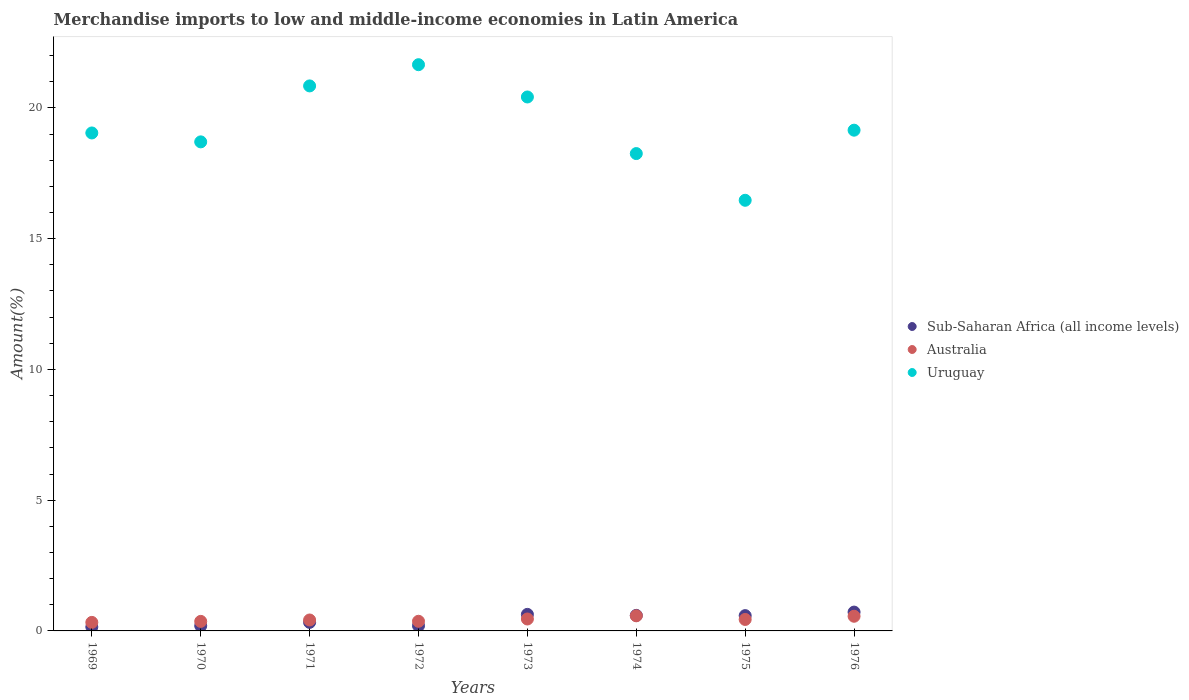How many different coloured dotlines are there?
Ensure brevity in your answer.  3. Is the number of dotlines equal to the number of legend labels?
Give a very brief answer. Yes. What is the percentage of amount earned from merchandise imports in Australia in 1975?
Offer a very short reply. 0.44. Across all years, what is the maximum percentage of amount earned from merchandise imports in Sub-Saharan Africa (all income levels)?
Provide a short and direct response. 0.72. Across all years, what is the minimum percentage of amount earned from merchandise imports in Australia?
Keep it short and to the point. 0.33. In which year was the percentage of amount earned from merchandise imports in Sub-Saharan Africa (all income levels) minimum?
Offer a very short reply. 1969. What is the total percentage of amount earned from merchandise imports in Uruguay in the graph?
Your answer should be compact. 154.52. What is the difference between the percentage of amount earned from merchandise imports in Sub-Saharan Africa (all income levels) in 1972 and that in 1974?
Ensure brevity in your answer.  -0.4. What is the difference between the percentage of amount earned from merchandise imports in Uruguay in 1969 and the percentage of amount earned from merchandise imports in Sub-Saharan Africa (all income levels) in 1976?
Ensure brevity in your answer.  18.32. What is the average percentage of amount earned from merchandise imports in Australia per year?
Make the answer very short. 0.44. In the year 1976, what is the difference between the percentage of amount earned from merchandise imports in Sub-Saharan Africa (all income levels) and percentage of amount earned from merchandise imports in Uruguay?
Your response must be concise. -18.43. What is the ratio of the percentage of amount earned from merchandise imports in Australia in 1969 to that in 1975?
Your answer should be compact. 0.74. Is the difference between the percentage of amount earned from merchandise imports in Sub-Saharan Africa (all income levels) in 1970 and 1973 greater than the difference between the percentage of amount earned from merchandise imports in Uruguay in 1970 and 1973?
Your answer should be very brief. Yes. What is the difference between the highest and the second highest percentage of amount earned from merchandise imports in Sub-Saharan Africa (all income levels)?
Provide a succinct answer. 0.09. What is the difference between the highest and the lowest percentage of amount earned from merchandise imports in Uruguay?
Give a very brief answer. 5.19. In how many years, is the percentage of amount earned from merchandise imports in Sub-Saharan Africa (all income levels) greater than the average percentage of amount earned from merchandise imports in Sub-Saharan Africa (all income levels) taken over all years?
Keep it short and to the point. 4. How many dotlines are there?
Keep it short and to the point. 3. How many years are there in the graph?
Offer a very short reply. 8. Are the values on the major ticks of Y-axis written in scientific E-notation?
Ensure brevity in your answer.  No. How are the legend labels stacked?
Your response must be concise. Vertical. What is the title of the graph?
Offer a terse response. Merchandise imports to low and middle-income economies in Latin America. Does "Equatorial Guinea" appear as one of the legend labels in the graph?
Your answer should be compact. No. What is the label or title of the X-axis?
Offer a very short reply. Years. What is the label or title of the Y-axis?
Offer a terse response. Amount(%). What is the Amount(%) in Sub-Saharan Africa (all income levels) in 1969?
Your answer should be very brief. 0.15. What is the Amount(%) in Australia in 1969?
Your response must be concise. 0.33. What is the Amount(%) of Uruguay in 1969?
Provide a succinct answer. 19.04. What is the Amount(%) of Sub-Saharan Africa (all income levels) in 1970?
Provide a succinct answer. 0.2. What is the Amount(%) in Australia in 1970?
Offer a terse response. 0.36. What is the Amount(%) of Uruguay in 1970?
Provide a short and direct response. 18.7. What is the Amount(%) in Sub-Saharan Africa (all income levels) in 1971?
Give a very brief answer. 0.33. What is the Amount(%) of Australia in 1971?
Give a very brief answer. 0.42. What is the Amount(%) in Uruguay in 1971?
Your response must be concise. 20.84. What is the Amount(%) of Sub-Saharan Africa (all income levels) in 1972?
Your response must be concise. 0.2. What is the Amount(%) of Australia in 1972?
Your response must be concise. 0.37. What is the Amount(%) in Uruguay in 1972?
Give a very brief answer. 21.65. What is the Amount(%) of Sub-Saharan Africa (all income levels) in 1973?
Give a very brief answer. 0.63. What is the Amount(%) of Australia in 1973?
Provide a short and direct response. 0.46. What is the Amount(%) of Uruguay in 1973?
Give a very brief answer. 20.42. What is the Amount(%) of Sub-Saharan Africa (all income levels) in 1974?
Your answer should be very brief. 0.59. What is the Amount(%) in Australia in 1974?
Your answer should be very brief. 0.58. What is the Amount(%) of Uruguay in 1974?
Your answer should be very brief. 18.25. What is the Amount(%) of Sub-Saharan Africa (all income levels) in 1975?
Offer a very short reply. 0.58. What is the Amount(%) in Australia in 1975?
Make the answer very short. 0.44. What is the Amount(%) of Uruguay in 1975?
Offer a very short reply. 16.47. What is the Amount(%) in Sub-Saharan Africa (all income levels) in 1976?
Make the answer very short. 0.72. What is the Amount(%) in Australia in 1976?
Provide a short and direct response. 0.56. What is the Amount(%) in Uruguay in 1976?
Give a very brief answer. 19.15. Across all years, what is the maximum Amount(%) in Sub-Saharan Africa (all income levels)?
Provide a short and direct response. 0.72. Across all years, what is the maximum Amount(%) of Australia?
Provide a short and direct response. 0.58. Across all years, what is the maximum Amount(%) in Uruguay?
Make the answer very short. 21.65. Across all years, what is the minimum Amount(%) of Sub-Saharan Africa (all income levels)?
Your answer should be compact. 0.15. Across all years, what is the minimum Amount(%) in Australia?
Your answer should be very brief. 0.33. Across all years, what is the minimum Amount(%) in Uruguay?
Ensure brevity in your answer.  16.47. What is the total Amount(%) in Sub-Saharan Africa (all income levels) in the graph?
Give a very brief answer. 3.4. What is the total Amount(%) of Australia in the graph?
Give a very brief answer. 3.51. What is the total Amount(%) in Uruguay in the graph?
Offer a very short reply. 154.52. What is the difference between the Amount(%) in Sub-Saharan Africa (all income levels) in 1969 and that in 1970?
Make the answer very short. -0.04. What is the difference between the Amount(%) in Australia in 1969 and that in 1970?
Your answer should be very brief. -0.04. What is the difference between the Amount(%) in Uruguay in 1969 and that in 1970?
Provide a succinct answer. 0.34. What is the difference between the Amount(%) in Sub-Saharan Africa (all income levels) in 1969 and that in 1971?
Your response must be concise. -0.18. What is the difference between the Amount(%) in Australia in 1969 and that in 1971?
Offer a very short reply. -0.09. What is the difference between the Amount(%) of Uruguay in 1969 and that in 1971?
Your response must be concise. -1.8. What is the difference between the Amount(%) in Sub-Saharan Africa (all income levels) in 1969 and that in 1972?
Offer a very short reply. -0.05. What is the difference between the Amount(%) in Australia in 1969 and that in 1972?
Your answer should be very brief. -0.04. What is the difference between the Amount(%) of Uruguay in 1969 and that in 1972?
Ensure brevity in your answer.  -2.61. What is the difference between the Amount(%) in Sub-Saharan Africa (all income levels) in 1969 and that in 1973?
Ensure brevity in your answer.  -0.48. What is the difference between the Amount(%) in Australia in 1969 and that in 1973?
Give a very brief answer. -0.13. What is the difference between the Amount(%) of Uruguay in 1969 and that in 1973?
Keep it short and to the point. -1.38. What is the difference between the Amount(%) in Sub-Saharan Africa (all income levels) in 1969 and that in 1974?
Your answer should be compact. -0.44. What is the difference between the Amount(%) of Australia in 1969 and that in 1974?
Keep it short and to the point. -0.25. What is the difference between the Amount(%) in Uruguay in 1969 and that in 1974?
Your response must be concise. 0.79. What is the difference between the Amount(%) in Sub-Saharan Africa (all income levels) in 1969 and that in 1975?
Give a very brief answer. -0.43. What is the difference between the Amount(%) in Australia in 1969 and that in 1975?
Your response must be concise. -0.11. What is the difference between the Amount(%) of Uruguay in 1969 and that in 1975?
Your response must be concise. 2.57. What is the difference between the Amount(%) of Sub-Saharan Africa (all income levels) in 1969 and that in 1976?
Provide a short and direct response. -0.57. What is the difference between the Amount(%) of Australia in 1969 and that in 1976?
Provide a short and direct response. -0.24. What is the difference between the Amount(%) in Uruguay in 1969 and that in 1976?
Offer a very short reply. -0.11. What is the difference between the Amount(%) of Sub-Saharan Africa (all income levels) in 1970 and that in 1971?
Offer a terse response. -0.13. What is the difference between the Amount(%) of Australia in 1970 and that in 1971?
Ensure brevity in your answer.  -0.05. What is the difference between the Amount(%) in Uruguay in 1970 and that in 1971?
Your response must be concise. -2.14. What is the difference between the Amount(%) in Sub-Saharan Africa (all income levels) in 1970 and that in 1972?
Give a very brief answer. -0. What is the difference between the Amount(%) in Australia in 1970 and that in 1972?
Make the answer very short. -0. What is the difference between the Amount(%) of Uruguay in 1970 and that in 1972?
Provide a short and direct response. -2.95. What is the difference between the Amount(%) of Sub-Saharan Africa (all income levels) in 1970 and that in 1973?
Provide a succinct answer. -0.44. What is the difference between the Amount(%) of Australia in 1970 and that in 1973?
Give a very brief answer. -0.09. What is the difference between the Amount(%) in Uruguay in 1970 and that in 1973?
Give a very brief answer. -1.72. What is the difference between the Amount(%) in Sub-Saharan Africa (all income levels) in 1970 and that in 1974?
Provide a short and direct response. -0.4. What is the difference between the Amount(%) of Australia in 1970 and that in 1974?
Your answer should be very brief. -0.21. What is the difference between the Amount(%) in Uruguay in 1970 and that in 1974?
Make the answer very short. 0.45. What is the difference between the Amount(%) in Sub-Saharan Africa (all income levels) in 1970 and that in 1975?
Provide a short and direct response. -0.39. What is the difference between the Amount(%) of Australia in 1970 and that in 1975?
Your answer should be compact. -0.07. What is the difference between the Amount(%) in Uruguay in 1970 and that in 1975?
Your answer should be compact. 2.23. What is the difference between the Amount(%) of Sub-Saharan Africa (all income levels) in 1970 and that in 1976?
Offer a terse response. -0.52. What is the difference between the Amount(%) in Australia in 1970 and that in 1976?
Your response must be concise. -0.2. What is the difference between the Amount(%) of Uruguay in 1970 and that in 1976?
Provide a short and direct response. -0.45. What is the difference between the Amount(%) of Sub-Saharan Africa (all income levels) in 1971 and that in 1972?
Provide a short and direct response. 0.13. What is the difference between the Amount(%) in Australia in 1971 and that in 1972?
Ensure brevity in your answer.  0.05. What is the difference between the Amount(%) in Uruguay in 1971 and that in 1972?
Your answer should be compact. -0.81. What is the difference between the Amount(%) in Sub-Saharan Africa (all income levels) in 1971 and that in 1973?
Ensure brevity in your answer.  -0.31. What is the difference between the Amount(%) in Australia in 1971 and that in 1973?
Ensure brevity in your answer.  -0.04. What is the difference between the Amount(%) of Uruguay in 1971 and that in 1973?
Offer a terse response. 0.42. What is the difference between the Amount(%) in Sub-Saharan Africa (all income levels) in 1971 and that in 1974?
Your response must be concise. -0.27. What is the difference between the Amount(%) in Australia in 1971 and that in 1974?
Provide a short and direct response. -0.16. What is the difference between the Amount(%) of Uruguay in 1971 and that in 1974?
Provide a succinct answer. 2.59. What is the difference between the Amount(%) in Sub-Saharan Africa (all income levels) in 1971 and that in 1975?
Offer a very short reply. -0.26. What is the difference between the Amount(%) of Australia in 1971 and that in 1975?
Your answer should be very brief. -0.02. What is the difference between the Amount(%) in Uruguay in 1971 and that in 1975?
Give a very brief answer. 4.37. What is the difference between the Amount(%) of Sub-Saharan Africa (all income levels) in 1971 and that in 1976?
Your response must be concise. -0.39. What is the difference between the Amount(%) in Australia in 1971 and that in 1976?
Provide a short and direct response. -0.14. What is the difference between the Amount(%) in Uruguay in 1971 and that in 1976?
Ensure brevity in your answer.  1.69. What is the difference between the Amount(%) of Sub-Saharan Africa (all income levels) in 1972 and that in 1973?
Your answer should be very brief. -0.43. What is the difference between the Amount(%) in Australia in 1972 and that in 1973?
Provide a succinct answer. -0.09. What is the difference between the Amount(%) of Uruguay in 1972 and that in 1973?
Your answer should be compact. 1.23. What is the difference between the Amount(%) in Sub-Saharan Africa (all income levels) in 1972 and that in 1974?
Your answer should be compact. -0.4. What is the difference between the Amount(%) in Australia in 1972 and that in 1974?
Make the answer very short. -0.21. What is the difference between the Amount(%) in Uruguay in 1972 and that in 1974?
Keep it short and to the point. 3.4. What is the difference between the Amount(%) in Sub-Saharan Africa (all income levels) in 1972 and that in 1975?
Keep it short and to the point. -0.39. What is the difference between the Amount(%) in Australia in 1972 and that in 1975?
Ensure brevity in your answer.  -0.07. What is the difference between the Amount(%) of Uruguay in 1972 and that in 1975?
Your answer should be very brief. 5.19. What is the difference between the Amount(%) of Sub-Saharan Africa (all income levels) in 1972 and that in 1976?
Your answer should be very brief. -0.52. What is the difference between the Amount(%) in Australia in 1972 and that in 1976?
Make the answer very short. -0.19. What is the difference between the Amount(%) in Uruguay in 1972 and that in 1976?
Offer a very short reply. 2.5. What is the difference between the Amount(%) of Sub-Saharan Africa (all income levels) in 1973 and that in 1974?
Offer a very short reply. 0.04. What is the difference between the Amount(%) in Australia in 1973 and that in 1974?
Offer a terse response. -0.12. What is the difference between the Amount(%) of Uruguay in 1973 and that in 1974?
Keep it short and to the point. 2.16. What is the difference between the Amount(%) in Sub-Saharan Africa (all income levels) in 1973 and that in 1975?
Ensure brevity in your answer.  0.05. What is the difference between the Amount(%) of Australia in 1973 and that in 1975?
Make the answer very short. 0.02. What is the difference between the Amount(%) in Uruguay in 1973 and that in 1975?
Your answer should be very brief. 3.95. What is the difference between the Amount(%) of Sub-Saharan Africa (all income levels) in 1973 and that in 1976?
Offer a very short reply. -0.09. What is the difference between the Amount(%) in Australia in 1973 and that in 1976?
Provide a succinct answer. -0.1. What is the difference between the Amount(%) of Uruguay in 1973 and that in 1976?
Provide a short and direct response. 1.27. What is the difference between the Amount(%) in Sub-Saharan Africa (all income levels) in 1974 and that in 1975?
Make the answer very short. 0.01. What is the difference between the Amount(%) in Australia in 1974 and that in 1975?
Offer a very short reply. 0.14. What is the difference between the Amount(%) in Uruguay in 1974 and that in 1975?
Your response must be concise. 1.79. What is the difference between the Amount(%) in Sub-Saharan Africa (all income levels) in 1974 and that in 1976?
Give a very brief answer. -0.13. What is the difference between the Amount(%) of Australia in 1974 and that in 1976?
Give a very brief answer. 0.02. What is the difference between the Amount(%) of Uruguay in 1974 and that in 1976?
Offer a terse response. -0.89. What is the difference between the Amount(%) of Sub-Saharan Africa (all income levels) in 1975 and that in 1976?
Make the answer very short. -0.14. What is the difference between the Amount(%) of Australia in 1975 and that in 1976?
Provide a succinct answer. -0.12. What is the difference between the Amount(%) of Uruguay in 1975 and that in 1976?
Make the answer very short. -2.68. What is the difference between the Amount(%) in Sub-Saharan Africa (all income levels) in 1969 and the Amount(%) in Australia in 1970?
Your answer should be very brief. -0.21. What is the difference between the Amount(%) in Sub-Saharan Africa (all income levels) in 1969 and the Amount(%) in Uruguay in 1970?
Provide a succinct answer. -18.55. What is the difference between the Amount(%) in Australia in 1969 and the Amount(%) in Uruguay in 1970?
Provide a succinct answer. -18.38. What is the difference between the Amount(%) in Sub-Saharan Africa (all income levels) in 1969 and the Amount(%) in Australia in 1971?
Offer a terse response. -0.27. What is the difference between the Amount(%) of Sub-Saharan Africa (all income levels) in 1969 and the Amount(%) of Uruguay in 1971?
Provide a short and direct response. -20.69. What is the difference between the Amount(%) of Australia in 1969 and the Amount(%) of Uruguay in 1971?
Make the answer very short. -20.52. What is the difference between the Amount(%) of Sub-Saharan Africa (all income levels) in 1969 and the Amount(%) of Australia in 1972?
Your response must be concise. -0.22. What is the difference between the Amount(%) of Sub-Saharan Africa (all income levels) in 1969 and the Amount(%) of Uruguay in 1972?
Provide a succinct answer. -21.5. What is the difference between the Amount(%) of Australia in 1969 and the Amount(%) of Uruguay in 1972?
Keep it short and to the point. -21.33. What is the difference between the Amount(%) in Sub-Saharan Africa (all income levels) in 1969 and the Amount(%) in Australia in 1973?
Your answer should be compact. -0.31. What is the difference between the Amount(%) in Sub-Saharan Africa (all income levels) in 1969 and the Amount(%) in Uruguay in 1973?
Offer a very short reply. -20.27. What is the difference between the Amount(%) of Australia in 1969 and the Amount(%) of Uruguay in 1973?
Your response must be concise. -20.09. What is the difference between the Amount(%) of Sub-Saharan Africa (all income levels) in 1969 and the Amount(%) of Australia in 1974?
Your response must be concise. -0.43. What is the difference between the Amount(%) in Sub-Saharan Africa (all income levels) in 1969 and the Amount(%) in Uruguay in 1974?
Ensure brevity in your answer.  -18.1. What is the difference between the Amount(%) in Australia in 1969 and the Amount(%) in Uruguay in 1974?
Ensure brevity in your answer.  -17.93. What is the difference between the Amount(%) of Sub-Saharan Africa (all income levels) in 1969 and the Amount(%) of Australia in 1975?
Give a very brief answer. -0.29. What is the difference between the Amount(%) in Sub-Saharan Africa (all income levels) in 1969 and the Amount(%) in Uruguay in 1975?
Give a very brief answer. -16.32. What is the difference between the Amount(%) of Australia in 1969 and the Amount(%) of Uruguay in 1975?
Offer a terse response. -16.14. What is the difference between the Amount(%) of Sub-Saharan Africa (all income levels) in 1969 and the Amount(%) of Australia in 1976?
Ensure brevity in your answer.  -0.41. What is the difference between the Amount(%) of Sub-Saharan Africa (all income levels) in 1969 and the Amount(%) of Uruguay in 1976?
Make the answer very short. -19. What is the difference between the Amount(%) in Australia in 1969 and the Amount(%) in Uruguay in 1976?
Ensure brevity in your answer.  -18.82. What is the difference between the Amount(%) in Sub-Saharan Africa (all income levels) in 1970 and the Amount(%) in Australia in 1971?
Your answer should be very brief. -0.22. What is the difference between the Amount(%) of Sub-Saharan Africa (all income levels) in 1970 and the Amount(%) of Uruguay in 1971?
Provide a succinct answer. -20.65. What is the difference between the Amount(%) of Australia in 1970 and the Amount(%) of Uruguay in 1971?
Give a very brief answer. -20.48. What is the difference between the Amount(%) of Sub-Saharan Africa (all income levels) in 1970 and the Amount(%) of Australia in 1972?
Offer a terse response. -0.17. What is the difference between the Amount(%) of Sub-Saharan Africa (all income levels) in 1970 and the Amount(%) of Uruguay in 1972?
Offer a very short reply. -21.46. What is the difference between the Amount(%) in Australia in 1970 and the Amount(%) in Uruguay in 1972?
Provide a short and direct response. -21.29. What is the difference between the Amount(%) in Sub-Saharan Africa (all income levels) in 1970 and the Amount(%) in Australia in 1973?
Provide a short and direct response. -0.26. What is the difference between the Amount(%) in Sub-Saharan Africa (all income levels) in 1970 and the Amount(%) in Uruguay in 1973?
Make the answer very short. -20.22. What is the difference between the Amount(%) of Australia in 1970 and the Amount(%) of Uruguay in 1973?
Your response must be concise. -20.05. What is the difference between the Amount(%) in Sub-Saharan Africa (all income levels) in 1970 and the Amount(%) in Australia in 1974?
Make the answer very short. -0.38. What is the difference between the Amount(%) of Sub-Saharan Africa (all income levels) in 1970 and the Amount(%) of Uruguay in 1974?
Offer a very short reply. -18.06. What is the difference between the Amount(%) in Australia in 1970 and the Amount(%) in Uruguay in 1974?
Give a very brief answer. -17.89. What is the difference between the Amount(%) in Sub-Saharan Africa (all income levels) in 1970 and the Amount(%) in Australia in 1975?
Your answer should be compact. -0.24. What is the difference between the Amount(%) of Sub-Saharan Africa (all income levels) in 1970 and the Amount(%) of Uruguay in 1975?
Your response must be concise. -16.27. What is the difference between the Amount(%) of Australia in 1970 and the Amount(%) of Uruguay in 1975?
Your answer should be compact. -16.1. What is the difference between the Amount(%) in Sub-Saharan Africa (all income levels) in 1970 and the Amount(%) in Australia in 1976?
Offer a very short reply. -0.37. What is the difference between the Amount(%) in Sub-Saharan Africa (all income levels) in 1970 and the Amount(%) in Uruguay in 1976?
Your answer should be very brief. -18.95. What is the difference between the Amount(%) of Australia in 1970 and the Amount(%) of Uruguay in 1976?
Your answer should be compact. -18.78. What is the difference between the Amount(%) of Sub-Saharan Africa (all income levels) in 1971 and the Amount(%) of Australia in 1972?
Give a very brief answer. -0.04. What is the difference between the Amount(%) in Sub-Saharan Africa (all income levels) in 1971 and the Amount(%) in Uruguay in 1972?
Offer a terse response. -21.33. What is the difference between the Amount(%) in Australia in 1971 and the Amount(%) in Uruguay in 1972?
Give a very brief answer. -21.23. What is the difference between the Amount(%) of Sub-Saharan Africa (all income levels) in 1971 and the Amount(%) of Australia in 1973?
Your answer should be very brief. -0.13. What is the difference between the Amount(%) of Sub-Saharan Africa (all income levels) in 1971 and the Amount(%) of Uruguay in 1973?
Provide a short and direct response. -20.09. What is the difference between the Amount(%) in Australia in 1971 and the Amount(%) in Uruguay in 1973?
Give a very brief answer. -20. What is the difference between the Amount(%) of Sub-Saharan Africa (all income levels) in 1971 and the Amount(%) of Australia in 1974?
Offer a very short reply. -0.25. What is the difference between the Amount(%) in Sub-Saharan Africa (all income levels) in 1971 and the Amount(%) in Uruguay in 1974?
Give a very brief answer. -17.93. What is the difference between the Amount(%) in Australia in 1971 and the Amount(%) in Uruguay in 1974?
Offer a terse response. -17.84. What is the difference between the Amount(%) of Sub-Saharan Africa (all income levels) in 1971 and the Amount(%) of Australia in 1975?
Give a very brief answer. -0.11. What is the difference between the Amount(%) in Sub-Saharan Africa (all income levels) in 1971 and the Amount(%) in Uruguay in 1975?
Provide a succinct answer. -16.14. What is the difference between the Amount(%) of Australia in 1971 and the Amount(%) of Uruguay in 1975?
Provide a short and direct response. -16.05. What is the difference between the Amount(%) of Sub-Saharan Africa (all income levels) in 1971 and the Amount(%) of Australia in 1976?
Your answer should be compact. -0.23. What is the difference between the Amount(%) in Sub-Saharan Africa (all income levels) in 1971 and the Amount(%) in Uruguay in 1976?
Your response must be concise. -18.82. What is the difference between the Amount(%) of Australia in 1971 and the Amount(%) of Uruguay in 1976?
Offer a very short reply. -18.73. What is the difference between the Amount(%) in Sub-Saharan Africa (all income levels) in 1972 and the Amount(%) in Australia in 1973?
Make the answer very short. -0.26. What is the difference between the Amount(%) of Sub-Saharan Africa (all income levels) in 1972 and the Amount(%) of Uruguay in 1973?
Your response must be concise. -20.22. What is the difference between the Amount(%) of Australia in 1972 and the Amount(%) of Uruguay in 1973?
Make the answer very short. -20.05. What is the difference between the Amount(%) of Sub-Saharan Africa (all income levels) in 1972 and the Amount(%) of Australia in 1974?
Provide a short and direct response. -0.38. What is the difference between the Amount(%) of Sub-Saharan Africa (all income levels) in 1972 and the Amount(%) of Uruguay in 1974?
Your response must be concise. -18.06. What is the difference between the Amount(%) of Australia in 1972 and the Amount(%) of Uruguay in 1974?
Make the answer very short. -17.88. What is the difference between the Amount(%) of Sub-Saharan Africa (all income levels) in 1972 and the Amount(%) of Australia in 1975?
Your answer should be compact. -0.24. What is the difference between the Amount(%) in Sub-Saharan Africa (all income levels) in 1972 and the Amount(%) in Uruguay in 1975?
Provide a succinct answer. -16.27. What is the difference between the Amount(%) of Australia in 1972 and the Amount(%) of Uruguay in 1975?
Make the answer very short. -16.1. What is the difference between the Amount(%) of Sub-Saharan Africa (all income levels) in 1972 and the Amount(%) of Australia in 1976?
Keep it short and to the point. -0.36. What is the difference between the Amount(%) of Sub-Saharan Africa (all income levels) in 1972 and the Amount(%) of Uruguay in 1976?
Your answer should be very brief. -18.95. What is the difference between the Amount(%) in Australia in 1972 and the Amount(%) in Uruguay in 1976?
Give a very brief answer. -18.78. What is the difference between the Amount(%) in Sub-Saharan Africa (all income levels) in 1973 and the Amount(%) in Australia in 1974?
Keep it short and to the point. 0.05. What is the difference between the Amount(%) in Sub-Saharan Africa (all income levels) in 1973 and the Amount(%) in Uruguay in 1974?
Offer a terse response. -17.62. What is the difference between the Amount(%) in Australia in 1973 and the Amount(%) in Uruguay in 1974?
Your answer should be compact. -17.8. What is the difference between the Amount(%) in Sub-Saharan Africa (all income levels) in 1973 and the Amount(%) in Australia in 1975?
Offer a terse response. 0.19. What is the difference between the Amount(%) of Sub-Saharan Africa (all income levels) in 1973 and the Amount(%) of Uruguay in 1975?
Provide a short and direct response. -15.83. What is the difference between the Amount(%) in Australia in 1973 and the Amount(%) in Uruguay in 1975?
Offer a terse response. -16.01. What is the difference between the Amount(%) of Sub-Saharan Africa (all income levels) in 1973 and the Amount(%) of Australia in 1976?
Your response must be concise. 0.07. What is the difference between the Amount(%) of Sub-Saharan Africa (all income levels) in 1973 and the Amount(%) of Uruguay in 1976?
Ensure brevity in your answer.  -18.52. What is the difference between the Amount(%) in Australia in 1973 and the Amount(%) in Uruguay in 1976?
Your response must be concise. -18.69. What is the difference between the Amount(%) of Sub-Saharan Africa (all income levels) in 1974 and the Amount(%) of Australia in 1975?
Offer a very short reply. 0.16. What is the difference between the Amount(%) of Sub-Saharan Africa (all income levels) in 1974 and the Amount(%) of Uruguay in 1975?
Keep it short and to the point. -15.87. What is the difference between the Amount(%) in Australia in 1974 and the Amount(%) in Uruguay in 1975?
Give a very brief answer. -15.89. What is the difference between the Amount(%) in Sub-Saharan Africa (all income levels) in 1974 and the Amount(%) in Australia in 1976?
Offer a very short reply. 0.03. What is the difference between the Amount(%) of Sub-Saharan Africa (all income levels) in 1974 and the Amount(%) of Uruguay in 1976?
Provide a short and direct response. -18.55. What is the difference between the Amount(%) in Australia in 1974 and the Amount(%) in Uruguay in 1976?
Your response must be concise. -18.57. What is the difference between the Amount(%) of Sub-Saharan Africa (all income levels) in 1975 and the Amount(%) of Australia in 1976?
Your answer should be very brief. 0.02. What is the difference between the Amount(%) of Sub-Saharan Africa (all income levels) in 1975 and the Amount(%) of Uruguay in 1976?
Offer a terse response. -18.56. What is the difference between the Amount(%) of Australia in 1975 and the Amount(%) of Uruguay in 1976?
Keep it short and to the point. -18.71. What is the average Amount(%) in Sub-Saharan Africa (all income levels) per year?
Your response must be concise. 0.43. What is the average Amount(%) of Australia per year?
Your answer should be compact. 0.44. What is the average Amount(%) of Uruguay per year?
Give a very brief answer. 19.32. In the year 1969, what is the difference between the Amount(%) of Sub-Saharan Africa (all income levels) and Amount(%) of Australia?
Your response must be concise. -0.17. In the year 1969, what is the difference between the Amount(%) in Sub-Saharan Africa (all income levels) and Amount(%) in Uruguay?
Your response must be concise. -18.89. In the year 1969, what is the difference between the Amount(%) in Australia and Amount(%) in Uruguay?
Offer a very short reply. -18.72. In the year 1970, what is the difference between the Amount(%) of Sub-Saharan Africa (all income levels) and Amount(%) of Australia?
Offer a terse response. -0.17. In the year 1970, what is the difference between the Amount(%) of Sub-Saharan Africa (all income levels) and Amount(%) of Uruguay?
Your answer should be compact. -18.51. In the year 1970, what is the difference between the Amount(%) in Australia and Amount(%) in Uruguay?
Offer a very short reply. -18.34. In the year 1971, what is the difference between the Amount(%) in Sub-Saharan Africa (all income levels) and Amount(%) in Australia?
Your answer should be very brief. -0.09. In the year 1971, what is the difference between the Amount(%) in Sub-Saharan Africa (all income levels) and Amount(%) in Uruguay?
Give a very brief answer. -20.51. In the year 1971, what is the difference between the Amount(%) in Australia and Amount(%) in Uruguay?
Your answer should be compact. -20.42. In the year 1972, what is the difference between the Amount(%) in Sub-Saharan Africa (all income levels) and Amount(%) in Australia?
Offer a terse response. -0.17. In the year 1972, what is the difference between the Amount(%) in Sub-Saharan Africa (all income levels) and Amount(%) in Uruguay?
Provide a short and direct response. -21.45. In the year 1972, what is the difference between the Amount(%) of Australia and Amount(%) of Uruguay?
Provide a succinct answer. -21.28. In the year 1973, what is the difference between the Amount(%) of Sub-Saharan Africa (all income levels) and Amount(%) of Australia?
Keep it short and to the point. 0.18. In the year 1973, what is the difference between the Amount(%) of Sub-Saharan Africa (all income levels) and Amount(%) of Uruguay?
Keep it short and to the point. -19.79. In the year 1973, what is the difference between the Amount(%) in Australia and Amount(%) in Uruguay?
Keep it short and to the point. -19.96. In the year 1974, what is the difference between the Amount(%) in Sub-Saharan Africa (all income levels) and Amount(%) in Australia?
Your response must be concise. 0.02. In the year 1974, what is the difference between the Amount(%) in Sub-Saharan Africa (all income levels) and Amount(%) in Uruguay?
Give a very brief answer. -17.66. In the year 1974, what is the difference between the Amount(%) in Australia and Amount(%) in Uruguay?
Offer a very short reply. -17.68. In the year 1975, what is the difference between the Amount(%) of Sub-Saharan Africa (all income levels) and Amount(%) of Australia?
Provide a short and direct response. 0.15. In the year 1975, what is the difference between the Amount(%) of Sub-Saharan Africa (all income levels) and Amount(%) of Uruguay?
Offer a very short reply. -15.88. In the year 1975, what is the difference between the Amount(%) of Australia and Amount(%) of Uruguay?
Your response must be concise. -16.03. In the year 1976, what is the difference between the Amount(%) in Sub-Saharan Africa (all income levels) and Amount(%) in Australia?
Ensure brevity in your answer.  0.16. In the year 1976, what is the difference between the Amount(%) of Sub-Saharan Africa (all income levels) and Amount(%) of Uruguay?
Give a very brief answer. -18.43. In the year 1976, what is the difference between the Amount(%) of Australia and Amount(%) of Uruguay?
Provide a short and direct response. -18.59. What is the ratio of the Amount(%) of Sub-Saharan Africa (all income levels) in 1969 to that in 1970?
Ensure brevity in your answer.  0.77. What is the ratio of the Amount(%) of Australia in 1969 to that in 1970?
Give a very brief answer. 0.89. What is the ratio of the Amount(%) of Uruguay in 1969 to that in 1970?
Make the answer very short. 1.02. What is the ratio of the Amount(%) in Sub-Saharan Africa (all income levels) in 1969 to that in 1971?
Keep it short and to the point. 0.46. What is the ratio of the Amount(%) of Australia in 1969 to that in 1971?
Provide a succinct answer. 0.78. What is the ratio of the Amount(%) in Uruguay in 1969 to that in 1971?
Ensure brevity in your answer.  0.91. What is the ratio of the Amount(%) in Sub-Saharan Africa (all income levels) in 1969 to that in 1972?
Your answer should be compact. 0.76. What is the ratio of the Amount(%) of Australia in 1969 to that in 1972?
Keep it short and to the point. 0.88. What is the ratio of the Amount(%) of Uruguay in 1969 to that in 1972?
Offer a very short reply. 0.88. What is the ratio of the Amount(%) in Sub-Saharan Africa (all income levels) in 1969 to that in 1973?
Keep it short and to the point. 0.24. What is the ratio of the Amount(%) of Australia in 1969 to that in 1973?
Make the answer very short. 0.71. What is the ratio of the Amount(%) in Uruguay in 1969 to that in 1973?
Your answer should be very brief. 0.93. What is the ratio of the Amount(%) of Sub-Saharan Africa (all income levels) in 1969 to that in 1974?
Provide a succinct answer. 0.25. What is the ratio of the Amount(%) in Australia in 1969 to that in 1974?
Provide a short and direct response. 0.56. What is the ratio of the Amount(%) in Uruguay in 1969 to that in 1974?
Ensure brevity in your answer.  1.04. What is the ratio of the Amount(%) of Sub-Saharan Africa (all income levels) in 1969 to that in 1975?
Make the answer very short. 0.26. What is the ratio of the Amount(%) of Australia in 1969 to that in 1975?
Provide a succinct answer. 0.74. What is the ratio of the Amount(%) of Uruguay in 1969 to that in 1975?
Make the answer very short. 1.16. What is the ratio of the Amount(%) of Sub-Saharan Africa (all income levels) in 1969 to that in 1976?
Keep it short and to the point. 0.21. What is the ratio of the Amount(%) of Australia in 1969 to that in 1976?
Your response must be concise. 0.58. What is the ratio of the Amount(%) of Sub-Saharan Africa (all income levels) in 1970 to that in 1971?
Provide a short and direct response. 0.6. What is the ratio of the Amount(%) of Australia in 1970 to that in 1971?
Ensure brevity in your answer.  0.87. What is the ratio of the Amount(%) of Uruguay in 1970 to that in 1971?
Your answer should be very brief. 0.9. What is the ratio of the Amount(%) in Sub-Saharan Africa (all income levels) in 1970 to that in 1972?
Keep it short and to the point. 0.99. What is the ratio of the Amount(%) of Australia in 1970 to that in 1972?
Offer a very short reply. 0.99. What is the ratio of the Amount(%) in Uruguay in 1970 to that in 1972?
Your response must be concise. 0.86. What is the ratio of the Amount(%) of Sub-Saharan Africa (all income levels) in 1970 to that in 1973?
Keep it short and to the point. 0.31. What is the ratio of the Amount(%) of Australia in 1970 to that in 1973?
Your answer should be compact. 0.8. What is the ratio of the Amount(%) of Uruguay in 1970 to that in 1973?
Your answer should be very brief. 0.92. What is the ratio of the Amount(%) of Sub-Saharan Africa (all income levels) in 1970 to that in 1974?
Provide a succinct answer. 0.33. What is the ratio of the Amount(%) in Australia in 1970 to that in 1974?
Provide a succinct answer. 0.63. What is the ratio of the Amount(%) of Uruguay in 1970 to that in 1974?
Keep it short and to the point. 1.02. What is the ratio of the Amount(%) in Sub-Saharan Africa (all income levels) in 1970 to that in 1975?
Provide a short and direct response. 0.33. What is the ratio of the Amount(%) in Australia in 1970 to that in 1975?
Offer a terse response. 0.83. What is the ratio of the Amount(%) in Uruguay in 1970 to that in 1975?
Provide a succinct answer. 1.14. What is the ratio of the Amount(%) in Sub-Saharan Africa (all income levels) in 1970 to that in 1976?
Give a very brief answer. 0.27. What is the ratio of the Amount(%) in Australia in 1970 to that in 1976?
Make the answer very short. 0.65. What is the ratio of the Amount(%) of Uruguay in 1970 to that in 1976?
Your response must be concise. 0.98. What is the ratio of the Amount(%) of Sub-Saharan Africa (all income levels) in 1971 to that in 1972?
Offer a terse response. 1.66. What is the ratio of the Amount(%) in Australia in 1971 to that in 1972?
Your answer should be very brief. 1.13. What is the ratio of the Amount(%) in Uruguay in 1971 to that in 1972?
Give a very brief answer. 0.96. What is the ratio of the Amount(%) of Sub-Saharan Africa (all income levels) in 1971 to that in 1973?
Provide a short and direct response. 0.52. What is the ratio of the Amount(%) of Australia in 1971 to that in 1973?
Offer a terse response. 0.92. What is the ratio of the Amount(%) of Uruguay in 1971 to that in 1973?
Your answer should be compact. 1.02. What is the ratio of the Amount(%) of Sub-Saharan Africa (all income levels) in 1971 to that in 1974?
Ensure brevity in your answer.  0.55. What is the ratio of the Amount(%) in Australia in 1971 to that in 1974?
Ensure brevity in your answer.  0.72. What is the ratio of the Amount(%) in Uruguay in 1971 to that in 1974?
Ensure brevity in your answer.  1.14. What is the ratio of the Amount(%) in Sub-Saharan Africa (all income levels) in 1971 to that in 1975?
Provide a short and direct response. 0.56. What is the ratio of the Amount(%) of Australia in 1971 to that in 1975?
Give a very brief answer. 0.95. What is the ratio of the Amount(%) in Uruguay in 1971 to that in 1975?
Your response must be concise. 1.27. What is the ratio of the Amount(%) in Sub-Saharan Africa (all income levels) in 1971 to that in 1976?
Offer a terse response. 0.45. What is the ratio of the Amount(%) of Australia in 1971 to that in 1976?
Provide a short and direct response. 0.75. What is the ratio of the Amount(%) in Uruguay in 1971 to that in 1976?
Make the answer very short. 1.09. What is the ratio of the Amount(%) in Sub-Saharan Africa (all income levels) in 1972 to that in 1973?
Give a very brief answer. 0.31. What is the ratio of the Amount(%) in Australia in 1972 to that in 1973?
Your response must be concise. 0.81. What is the ratio of the Amount(%) of Uruguay in 1972 to that in 1973?
Provide a succinct answer. 1.06. What is the ratio of the Amount(%) in Sub-Saharan Africa (all income levels) in 1972 to that in 1974?
Give a very brief answer. 0.33. What is the ratio of the Amount(%) in Australia in 1972 to that in 1974?
Keep it short and to the point. 0.64. What is the ratio of the Amount(%) of Uruguay in 1972 to that in 1974?
Provide a succinct answer. 1.19. What is the ratio of the Amount(%) of Sub-Saharan Africa (all income levels) in 1972 to that in 1975?
Your answer should be very brief. 0.34. What is the ratio of the Amount(%) in Australia in 1972 to that in 1975?
Your response must be concise. 0.84. What is the ratio of the Amount(%) of Uruguay in 1972 to that in 1975?
Your answer should be compact. 1.31. What is the ratio of the Amount(%) of Sub-Saharan Africa (all income levels) in 1972 to that in 1976?
Provide a succinct answer. 0.27. What is the ratio of the Amount(%) in Australia in 1972 to that in 1976?
Provide a succinct answer. 0.66. What is the ratio of the Amount(%) of Uruguay in 1972 to that in 1976?
Ensure brevity in your answer.  1.13. What is the ratio of the Amount(%) in Sub-Saharan Africa (all income levels) in 1973 to that in 1974?
Give a very brief answer. 1.06. What is the ratio of the Amount(%) in Australia in 1973 to that in 1974?
Keep it short and to the point. 0.79. What is the ratio of the Amount(%) of Uruguay in 1973 to that in 1974?
Give a very brief answer. 1.12. What is the ratio of the Amount(%) of Sub-Saharan Africa (all income levels) in 1973 to that in 1975?
Give a very brief answer. 1.08. What is the ratio of the Amount(%) of Australia in 1973 to that in 1975?
Your answer should be compact. 1.04. What is the ratio of the Amount(%) of Uruguay in 1973 to that in 1975?
Your response must be concise. 1.24. What is the ratio of the Amount(%) in Sub-Saharan Africa (all income levels) in 1973 to that in 1976?
Your answer should be compact. 0.88. What is the ratio of the Amount(%) of Australia in 1973 to that in 1976?
Your answer should be very brief. 0.81. What is the ratio of the Amount(%) in Uruguay in 1973 to that in 1976?
Offer a very short reply. 1.07. What is the ratio of the Amount(%) of Sub-Saharan Africa (all income levels) in 1974 to that in 1975?
Make the answer very short. 1.02. What is the ratio of the Amount(%) of Australia in 1974 to that in 1975?
Make the answer very short. 1.32. What is the ratio of the Amount(%) of Uruguay in 1974 to that in 1975?
Offer a terse response. 1.11. What is the ratio of the Amount(%) of Sub-Saharan Africa (all income levels) in 1974 to that in 1976?
Keep it short and to the point. 0.83. What is the ratio of the Amount(%) in Australia in 1974 to that in 1976?
Your answer should be compact. 1.03. What is the ratio of the Amount(%) of Uruguay in 1974 to that in 1976?
Offer a terse response. 0.95. What is the ratio of the Amount(%) in Sub-Saharan Africa (all income levels) in 1975 to that in 1976?
Provide a short and direct response. 0.81. What is the ratio of the Amount(%) in Australia in 1975 to that in 1976?
Keep it short and to the point. 0.78. What is the ratio of the Amount(%) of Uruguay in 1975 to that in 1976?
Ensure brevity in your answer.  0.86. What is the difference between the highest and the second highest Amount(%) in Sub-Saharan Africa (all income levels)?
Offer a very short reply. 0.09. What is the difference between the highest and the second highest Amount(%) of Australia?
Give a very brief answer. 0.02. What is the difference between the highest and the second highest Amount(%) in Uruguay?
Keep it short and to the point. 0.81. What is the difference between the highest and the lowest Amount(%) in Sub-Saharan Africa (all income levels)?
Your response must be concise. 0.57. What is the difference between the highest and the lowest Amount(%) in Australia?
Offer a very short reply. 0.25. What is the difference between the highest and the lowest Amount(%) in Uruguay?
Your answer should be compact. 5.19. 